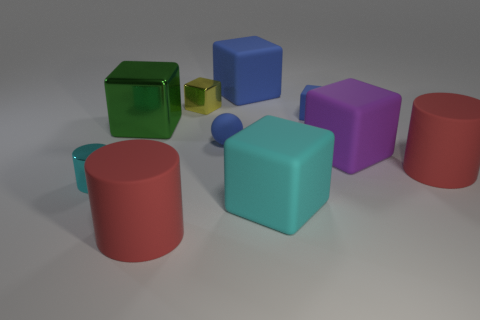Subtract all blue blocks. How many blocks are left? 4 Subtract all cyan cylinders. How many cylinders are left? 2 Subtract all cylinders. How many objects are left? 7 Subtract 2 cylinders. How many cylinders are left? 1 Add 5 cyan rubber objects. How many cyan rubber objects are left? 6 Add 7 tiny blue objects. How many tiny blue objects exist? 9 Subtract 0 gray cubes. How many objects are left? 10 Subtract all purple balls. Subtract all cyan blocks. How many balls are left? 1 Subtract all blue balls. How many cyan blocks are left? 1 Subtract all tiny metallic blocks. Subtract all big red objects. How many objects are left? 7 